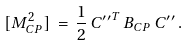Convert formula to latex. <formula><loc_0><loc_0><loc_500><loc_500>[ M ^ { 2 } _ { C P } ] \, = \, \frac { 1 } { 2 } \, { C ^ { \prime \prime } } ^ { T } \, B _ { C P } \, C ^ { \prime \prime } \, .</formula> 